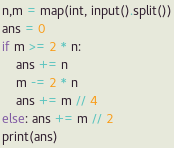Convert code to text. <code><loc_0><loc_0><loc_500><loc_500><_Python_>n,m = map(int, input().split())
ans = 0
if m >= 2 * n: 
    ans += n
    m -= 2 * n
    ans += m // 4
else: ans += m // 2
print(ans)</code> 